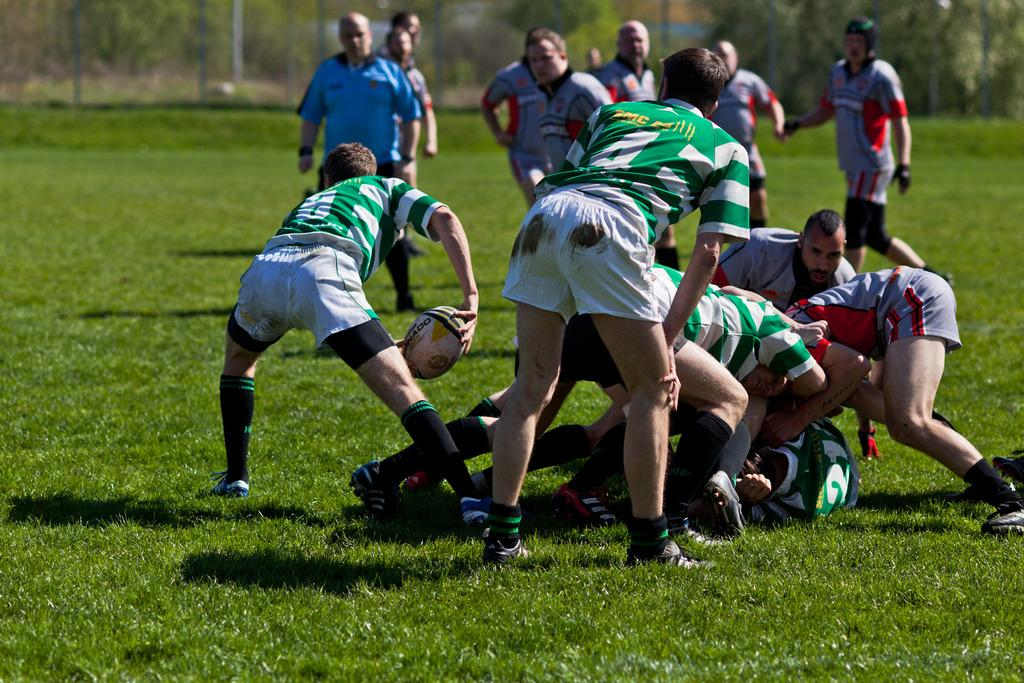What are the people in the image doing? The people in the image are playing. What surface are they playing on? They are playing on grass. What object is involved in their play? There is a ball involved in their play. What can be seen in the background of the image? There are trees in the background of the image. Are there any dinosaurs involved in the play in the image? No, there are no dinosaurs present in the image. Can you describe the type of fight occurring between the people in the image? There is no fight occurring between the people in the image; they are playing with a ball. 